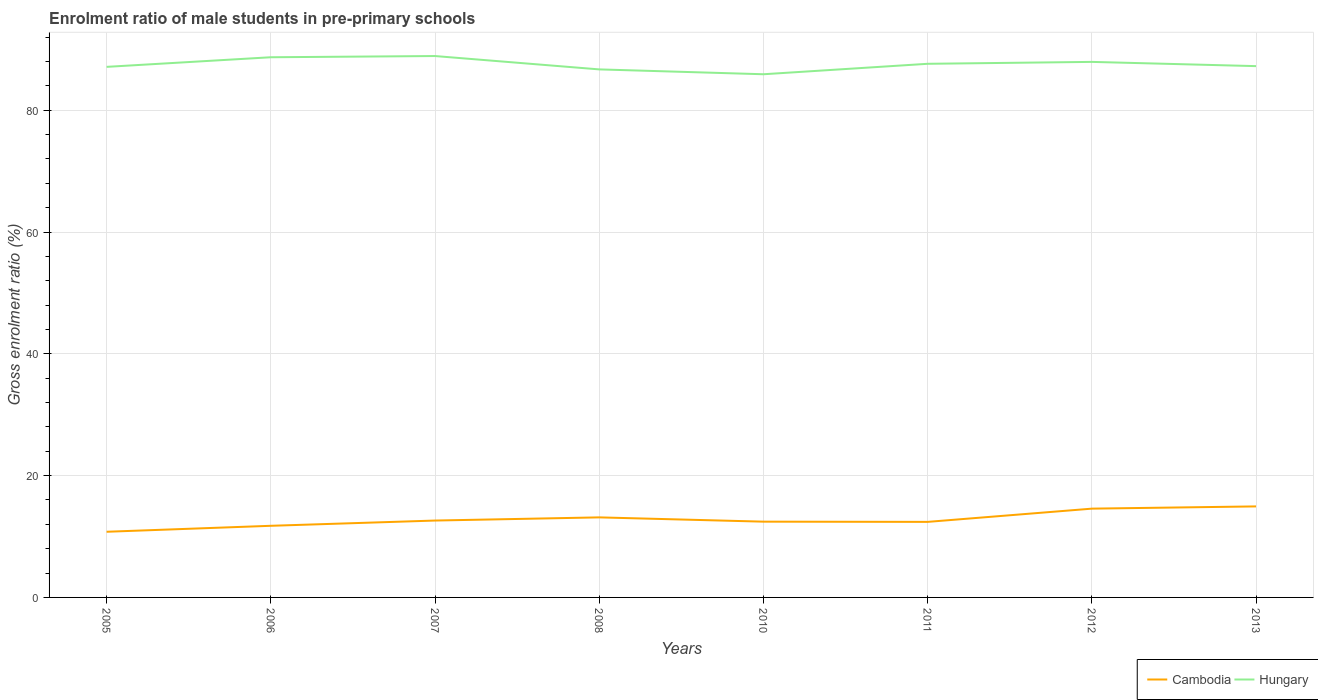Does the line corresponding to Cambodia intersect with the line corresponding to Hungary?
Your answer should be very brief. No. Is the number of lines equal to the number of legend labels?
Provide a succinct answer. Yes. Across all years, what is the maximum enrolment ratio of male students in pre-primary schools in Cambodia?
Your answer should be very brief. 10.78. What is the total enrolment ratio of male students in pre-primary schools in Cambodia in the graph?
Your response must be concise. 0.22. What is the difference between the highest and the second highest enrolment ratio of male students in pre-primary schools in Cambodia?
Provide a succinct answer. 4.16. How many lines are there?
Your answer should be very brief. 2. How many years are there in the graph?
Offer a terse response. 8. What is the difference between two consecutive major ticks on the Y-axis?
Ensure brevity in your answer.  20. Does the graph contain any zero values?
Provide a short and direct response. No. Does the graph contain grids?
Provide a succinct answer. Yes. How are the legend labels stacked?
Give a very brief answer. Horizontal. What is the title of the graph?
Ensure brevity in your answer.  Enrolment ratio of male students in pre-primary schools. What is the label or title of the X-axis?
Offer a terse response. Years. What is the label or title of the Y-axis?
Give a very brief answer. Gross enrolment ratio (%). What is the Gross enrolment ratio (%) of Cambodia in 2005?
Your answer should be compact. 10.78. What is the Gross enrolment ratio (%) of Hungary in 2005?
Give a very brief answer. 87.13. What is the Gross enrolment ratio (%) in Cambodia in 2006?
Your answer should be compact. 11.76. What is the Gross enrolment ratio (%) in Hungary in 2006?
Your response must be concise. 88.7. What is the Gross enrolment ratio (%) of Cambodia in 2007?
Offer a very short reply. 12.63. What is the Gross enrolment ratio (%) of Hungary in 2007?
Your response must be concise. 88.9. What is the Gross enrolment ratio (%) of Cambodia in 2008?
Your answer should be very brief. 13.15. What is the Gross enrolment ratio (%) of Hungary in 2008?
Your response must be concise. 86.71. What is the Gross enrolment ratio (%) in Cambodia in 2010?
Offer a very short reply. 12.44. What is the Gross enrolment ratio (%) in Hungary in 2010?
Your answer should be compact. 85.91. What is the Gross enrolment ratio (%) in Cambodia in 2011?
Keep it short and to the point. 12.41. What is the Gross enrolment ratio (%) in Hungary in 2011?
Ensure brevity in your answer.  87.63. What is the Gross enrolment ratio (%) in Cambodia in 2012?
Your response must be concise. 14.58. What is the Gross enrolment ratio (%) of Hungary in 2012?
Give a very brief answer. 87.94. What is the Gross enrolment ratio (%) of Cambodia in 2013?
Your answer should be very brief. 14.95. What is the Gross enrolment ratio (%) of Hungary in 2013?
Give a very brief answer. 87.25. Across all years, what is the maximum Gross enrolment ratio (%) in Cambodia?
Your answer should be compact. 14.95. Across all years, what is the maximum Gross enrolment ratio (%) in Hungary?
Provide a succinct answer. 88.9. Across all years, what is the minimum Gross enrolment ratio (%) in Cambodia?
Your answer should be very brief. 10.78. Across all years, what is the minimum Gross enrolment ratio (%) in Hungary?
Offer a very short reply. 85.91. What is the total Gross enrolment ratio (%) of Cambodia in the graph?
Give a very brief answer. 102.69. What is the total Gross enrolment ratio (%) of Hungary in the graph?
Give a very brief answer. 700.17. What is the difference between the Gross enrolment ratio (%) in Cambodia in 2005 and that in 2006?
Ensure brevity in your answer.  -0.98. What is the difference between the Gross enrolment ratio (%) in Hungary in 2005 and that in 2006?
Ensure brevity in your answer.  -1.58. What is the difference between the Gross enrolment ratio (%) in Cambodia in 2005 and that in 2007?
Give a very brief answer. -1.84. What is the difference between the Gross enrolment ratio (%) in Hungary in 2005 and that in 2007?
Ensure brevity in your answer.  -1.78. What is the difference between the Gross enrolment ratio (%) of Cambodia in 2005 and that in 2008?
Provide a succinct answer. -2.36. What is the difference between the Gross enrolment ratio (%) of Hungary in 2005 and that in 2008?
Your response must be concise. 0.42. What is the difference between the Gross enrolment ratio (%) of Cambodia in 2005 and that in 2010?
Provide a short and direct response. -1.66. What is the difference between the Gross enrolment ratio (%) of Hungary in 2005 and that in 2010?
Provide a succinct answer. 1.21. What is the difference between the Gross enrolment ratio (%) in Cambodia in 2005 and that in 2011?
Your answer should be compact. -1.62. What is the difference between the Gross enrolment ratio (%) of Hungary in 2005 and that in 2011?
Your answer should be very brief. -0.5. What is the difference between the Gross enrolment ratio (%) of Cambodia in 2005 and that in 2012?
Keep it short and to the point. -3.8. What is the difference between the Gross enrolment ratio (%) of Hungary in 2005 and that in 2012?
Provide a succinct answer. -0.82. What is the difference between the Gross enrolment ratio (%) of Cambodia in 2005 and that in 2013?
Your answer should be compact. -4.16. What is the difference between the Gross enrolment ratio (%) of Hungary in 2005 and that in 2013?
Provide a short and direct response. -0.12. What is the difference between the Gross enrolment ratio (%) of Cambodia in 2006 and that in 2007?
Your answer should be compact. -0.86. What is the difference between the Gross enrolment ratio (%) in Hungary in 2006 and that in 2007?
Ensure brevity in your answer.  -0.2. What is the difference between the Gross enrolment ratio (%) in Cambodia in 2006 and that in 2008?
Ensure brevity in your answer.  -1.38. What is the difference between the Gross enrolment ratio (%) in Hungary in 2006 and that in 2008?
Make the answer very short. 2. What is the difference between the Gross enrolment ratio (%) of Cambodia in 2006 and that in 2010?
Make the answer very short. -0.68. What is the difference between the Gross enrolment ratio (%) of Hungary in 2006 and that in 2010?
Your answer should be very brief. 2.79. What is the difference between the Gross enrolment ratio (%) of Cambodia in 2006 and that in 2011?
Provide a short and direct response. -0.64. What is the difference between the Gross enrolment ratio (%) of Hungary in 2006 and that in 2011?
Your answer should be compact. 1.08. What is the difference between the Gross enrolment ratio (%) of Cambodia in 2006 and that in 2012?
Offer a terse response. -2.82. What is the difference between the Gross enrolment ratio (%) of Hungary in 2006 and that in 2012?
Offer a very short reply. 0.76. What is the difference between the Gross enrolment ratio (%) of Cambodia in 2006 and that in 2013?
Ensure brevity in your answer.  -3.18. What is the difference between the Gross enrolment ratio (%) in Hungary in 2006 and that in 2013?
Your response must be concise. 1.46. What is the difference between the Gross enrolment ratio (%) of Cambodia in 2007 and that in 2008?
Your answer should be compact. -0.52. What is the difference between the Gross enrolment ratio (%) in Hungary in 2007 and that in 2008?
Provide a short and direct response. 2.19. What is the difference between the Gross enrolment ratio (%) in Cambodia in 2007 and that in 2010?
Provide a short and direct response. 0.18. What is the difference between the Gross enrolment ratio (%) of Hungary in 2007 and that in 2010?
Give a very brief answer. 2.99. What is the difference between the Gross enrolment ratio (%) of Cambodia in 2007 and that in 2011?
Provide a short and direct response. 0.22. What is the difference between the Gross enrolment ratio (%) of Hungary in 2007 and that in 2011?
Make the answer very short. 1.27. What is the difference between the Gross enrolment ratio (%) of Cambodia in 2007 and that in 2012?
Provide a short and direct response. -1.95. What is the difference between the Gross enrolment ratio (%) in Hungary in 2007 and that in 2012?
Your answer should be compact. 0.96. What is the difference between the Gross enrolment ratio (%) in Cambodia in 2007 and that in 2013?
Provide a succinct answer. -2.32. What is the difference between the Gross enrolment ratio (%) in Hungary in 2007 and that in 2013?
Your response must be concise. 1.66. What is the difference between the Gross enrolment ratio (%) of Cambodia in 2008 and that in 2010?
Offer a terse response. 0.7. What is the difference between the Gross enrolment ratio (%) of Hungary in 2008 and that in 2010?
Give a very brief answer. 0.8. What is the difference between the Gross enrolment ratio (%) of Cambodia in 2008 and that in 2011?
Provide a short and direct response. 0.74. What is the difference between the Gross enrolment ratio (%) in Hungary in 2008 and that in 2011?
Your response must be concise. -0.92. What is the difference between the Gross enrolment ratio (%) in Cambodia in 2008 and that in 2012?
Provide a succinct answer. -1.43. What is the difference between the Gross enrolment ratio (%) of Hungary in 2008 and that in 2012?
Provide a short and direct response. -1.23. What is the difference between the Gross enrolment ratio (%) in Cambodia in 2008 and that in 2013?
Keep it short and to the point. -1.8. What is the difference between the Gross enrolment ratio (%) of Hungary in 2008 and that in 2013?
Provide a succinct answer. -0.54. What is the difference between the Gross enrolment ratio (%) of Cambodia in 2010 and that in 2011?
Your response must be concise. 0.04. What is the difference between the Gross enrolment ratio (%) of Hungary in 2010 and that in 2011?
Your answer should be very brief. -1.72. What is the difference between the Gross enrolment ratio (%) of Cambodia in 2010 and that in 2012?
Provide a succinct answer. -2.14. What is the difference between the Gross enrolment ratio (%) of Hungary in 2010 and that in 2012?
Your response must be concise. -2.03. What is the difference between the Gross enrolment ratio (%) in Cambodia in 2010 and that in 2013?
Provide a short and direct response. -2.51. What is the difference between the Gross enrolment ratio (%) in Hungary in 2010 and that in 2013?
Ensure brevity in your answer.  -1.33. What is the difference between the Gross enrolment ratio (%) in Cambodia in 2011 and that in 2012?
Your answer should be very brief. -2.17. What is the difference between the Gross enrolment ratio (%) in Hungary in 2011 and that in 2012?
Ensure brevity in your answer.  -0.31. What is the difference between the Gross enrolment ratio (%) in Cambodia in 2011 and that in 2013?
Your answer should be very brief. -2.54. What is the difference between the Gross enrolment ratio (%) in Hungary in 2011 and that in 2013?
Your answer should be very brief. 0.38. What is the difference between the Gross enrolment ratio (%) in Cambodia in 2012 and that in 2013?
Give a very brief answer. -0.37. What is the difference between the Gross enrolment ratio (%) in Hungary in 2012 and that in 2013?
Offer a very short reply. 0.7. What is the difference between the Gross enrolment ratio (%) of Cambodia in 2005 and the Gross enrolment ratio (%) of Hungary in 2006?
Your answer should be very brief. -77.92. What is the difference between the Gross enrolment ratio (%) of Cambodia in 2005 and the Gross enrolment ratio (%) of Hungary in 2007?
Ensure brevity in your answer.  -78.12. What is the difference between the Gross enrolment ratio (%) in Cambodia in 2005 and the Gross enrolment ratio (%) in Hungary in 2008?
Offer a very short reply. -75.93. What is the difference between the Gross enrolment ratio (%) in Cambodia in 2005 and the Gross enrolment ratio (%) in Hungary in 2010?
Provide a short and direct response. -75.13. What is the difference between the Gross enrolment ratio (%) of Cambodia in 2005 and the Gross enrolment ratio (%) of Hungary in 2011?
Give a very brief answer. -76.85. What is the difference between the Gross enrolment ratio (%) of Cambodia in 2005 and the Gross enrolment ratio (%) of Hungary in 2012?
Your answer should be very brief. -77.16. What is the difference between the Gross enrolment ratio (%) of Cambodia in 2005 and the Gross enrolment ratio (%) of Hungary in 2013?
Give a very brief answer. -76.46. What is the difference between the Gross enrolment ratio (%) in Cambodia in 2006 and the Gross enrolment ratio (%) in Hungary in 2007?
Your answer should be compact. -77.14. What is the difference between the Gross enrolment ratio (%) of Cambodia in 2006 and the Gross enrolment ratio (%) of Hungary in 2008?
Your answer should be compact. -74.95. What is the difference between the Gross enrolment ratio (%) of Cambodia in 2006 and the Gross enrolment ratio (%) of Hungary in 2010?
Your answer should be compact. -74.15. What is the difference between the Gross enrolment ratio (%) of Cambodia in 2006 and the Gross enrolment ratio (%) of Hungary in 2011?
Make the answer very short. -75.87. What is the difference between the Gross enrolment ratio (%) in Cambodia in 2006 and the Gross enrolment ratio (%) in Hungary in 2012?
Keep it short and to the point. -76.18. What is the difference between the Gross enrolment ratio (%) in Cambodia in 2006 and the Gross enrolment ratio (%) in Hungary in 2013?
Offer a very short reply. -75.49. What is the difference between the Gross enrolment ratio (%) of Cambodia in 2007 and the Gross enrolment ratio (%) of Hungary in 2008?
Offer a terse response. -74.08. What is the difference between the Gross enrolment ratio (%) of Cambodia in 2007 and the Gross enrolment ratio (%) of Hungary in 2010?
Provide a short and direct response. -73.29. What is the difference between the Gross enrolment ratio (%) in Cambodia in 2007 and the Gross enrolment ratio (%) in Hungary in 2011?
Your answer should be very brief. -75. What is the difference between the Gross enrolment ratio (%) of Cambodia in 2007 and the Gross enrolment ratio (%) of Hungary in 2012?
Offer a terse response. -75.32. What is the difference between the Gross enrolment ratio (%) of Cambodia in 2007 and the Gross enrolment ratio (%) of Hungary in 2013?
Your response must be concise. -74.62. What is the difference between the Gross enrolment ratio (%) of Cambodia in 2008 and the Gross enrolment ratio (%) of Hungary in 2010?
Offer a terse response. -72.77. What is the difference between the Gross enrolment ratio (%) of Cambodia in 2008 and the Gross enrolment ratio (%) of Hungary in 2011?
Your response must be concise. -74.48. What is the difference between the Gross enrolment ratio (%) of Cambodia in 2008 and the Gross enrolment ratio (%) of Hungary in 2012?
Provide a short and direct response. -74.8. What is the difference between the Gross enrolment ratio (%) of Cambodia in 2008 and the Gross enrolment ratio (%) of Hungary in 2013?
Ensure brevity in your answer.  -74.1. What is the difference between the Gross enrolment ratio (%) in Cambodia in 2010 and the Gross enrolment ratio (%) in Hungary in 2011?
Keep it short and to the point. -75.19. What is the difference between the Gross enrolment ratio (%) of Cambodia in 2010 and the Gross enrolment ratio (%) of Hungary in 2012?
Provide a short and direct response. -75.5. What is the difference between the Gross enrolment ratio (%) in Cambodia in 2010 and the Gross enrolment ratio (%) in Hungary in 2013?
Make the answer very short. -74.81. What is the difference between the Gross enrolment ratio (%) in Cambodia in 2011 and the Gross enrolment ratio (%) in Hungary in 2012?
Your answer should be very brief. -75.54. What is the difference between the Gross enrolment ratio (%) of Cambodia in 2011 and the Gross enrolment ratio (%) of Hungary in 2013?
Make the answer very short. -74.84. What is the difference between the Gross enrolment ratio (%) of Cambodia in 2012 and the Gross enrolment ratio (%) of Hungary in 2013?
Offer a terse response. -72.67. What is the average Gross enrolment ratio (%) in Cambodia per year?
Your response must be concise. 12.84. What is the average Gross enrolment ratio (%) in Hungary per year?
Provide a short and direct response. 87.52. In the year 2005, what is the difference between the Gross enrolment ratio (%) in Cambodia and Gross enrolment ratio (%) in Hungary?
Give a very brief answer. -76.34. In the year 2006, what is the difference between the Gross enrolment ratio (%) of Cambodia and Gross enrolment ratio (%) of Hungary?
Provide a succinct answer. -76.94. In the year 2007, what is the difference between the Gross enrolment ratio (%) in Cambodia and Gross enrolment ratio (%) in Hungary?
Offer a terse response. -76.28. In the year 2008, what is the difference between the Gross enrolment ratio (%) of Cambodia and Gross enrolment ratio (%) of Hungary?
Provide a short and direct response. -73.56. In the year 2010, what is the difference between the Gross enrolment ratio (%) in Cambodia and Gross enrolment ratio (%) in Hungary?
Offer a very short reply. -73.47. In the year 2011, what is the difference between the Gross enrolment ratio (%) of Cambodia and Gross enrolment ratio (%) of Hungary?
Offer a terse response. -75.22. In the year 2012, what is the difference between the Gross enrolment ratio (%) of Cambodia and Gross enrolment ratio (%) of Hungary?
Your response must be concise. -73.36. In the year 2013, what is the difference between the Gross enrolment ratio (%) of Cambodia and Gross enrolment ratio (%) of Hungary?
Keep it short and to the point. -72.3. What is the ratio of the Gross enrolment ratio (%) in Hungary in 2005 to that in 2006?
Your answer should be very brief. 0.98. What is the ratio of the Gross enrolment ratio (%) of Cambodia in 2005 to that in 2007?
Offer a very short reply. 0.85. What is the ratio of the Gross enrolment ratio (%) in Hungary in 2005 to that in 2007?
Your answer should be very brief. 0.98. What is the ratio of the Gross enrolment ratio (%) in Cambodia in 2005 to that in 2008?
Offer a terse response. 0.82. What is the ratio of the Gross enrolment ratio (%) in Cambodia in 2005 to that in 2010?
Offer a terse response. 0.87. What is the ratio of the Gross enrolment ratio (%) of Hungary in 2005 to that in 2010?
Provide a succinct answer. 1.01. What is the ratio of the Gross enrolment ratio (%) of Cambodia in 2005 to that in 2011?
Offer a terse response. 0.87. What is the ratio of the Gross enrolment ratio (%) in Cambodia in 2005 to that in 2012?
Your answer should be compact. 0.74. What is the ratio of the Gross enrolment ratio (%) in Hungary in 2005 to that in 2012?
Make the answer very short. 0.99. What is the ratio of the Gross enrolment ratio (%) of Cambodia in 2005 to that in 2013?
Make the answer very short. 0.72. What is the ratio of the Gross enrolment ratio (%) in Hungary in 2005 to that in 2013?
Offer a terse response. 1. What is the ratio of the Gross enrolment ratio (%) of Cambodia in 2006 to that in 2007?
Ensure brevity in your answer.  0.93. What is the ratio of the Gross enrolment ratio (%) in Hungary in 2006 to that in 2007?
Make the answer very short. 1. What is the ratio of the Gross enrolment ratio (%) in Cambodia in 2006 to that in 2008?
Provide a short and direct response. 0.89. What is the ratio of the Gross enrolment ratio (%) in Cambodia in 2006 to that in 2010?
Keep it short and to the point. 0.95. What is the ratio of the Gross enrolment ratio (%) of Hungary in 2006 to that in 2010?
Offer a terse response. 1.03. What is the ratio of the Gross enrolment ratio (%) in Cambodia in 2006 to that in 2011?
Your response must be concise. 0.95. What is the ratio of the Gross enrolment ratio (%) of Hungary in 2006 to that in 2011?
Your answer should be compact. 1.01. What is the ratio of the Gross enrolment ratio (%) in Cambodia in 2006 to that in 2012?
Make the answer very short. 0.81. What is the ratio of the Gross enrolment ratio (%) in Hungary in 2006 to that in 2012?
Make the answer very short. 1.01. What is the ratio of the Gross enrolment ratio (%) in Cambodia in 2006 to that in 2013?
Keep it short and to the point. 0.79. What is the ratio of the Gross enrolment ratio (%) of Hungary in 2006 to that in 2013?
Your response must be concise. 1.02. What is the ratio of the Gross enrolment ratio (%) of Cambodia in 2007 to that in 2008?
Make the answer very short. 0.96. What is the ratio of the Gross enrolment ratio (%) in Hungary in 2007 to that in 2008?
Offer a very short reply. 1.03. What is the ratio of the Gross enrolment ratio (%) in Cambodia in 2007 to that in 2010?
Make the answer very short. 1.01. What is the ratio of the Gross enrolment ratio (%) in Hungary in 2007 to that in 2010?
Offer a very short reply. 1.03. What is the ratio of the Gross enrolment ratio (%) of Cambodia in 2007 to that in 2011?
Offer a terse response. 1.02. What is the ratio of the Gross enrolment ratio (%) in Hungary in 2007 to that in 2011?
Keep it short and to the point. 1.01. What is the ratio of the Gross enrolment ratio (%) of Cambodia in 2007 to that in 2012?
Your answer should be compact. 0.87. What is the ratio of the Gross enrolment ratio (%) of Hungary in 2007 to that in 2012?
Provide a short and direct response. 1.01. What is the ratio of the Gross enrolment ratio (%) of Cambodia in 2007 to that in 2013?
Offer a terse response. 0.84. What is the ratio of the Gross enrolment ratio (%) of Hungary in 2007 to that in 2013?
Provide a succinct answer. 1.02. What is the ratio of the Gross enrolment ratio (%) of Cambodia in 2008 to that in 2010?
Give a very brief answer. 1.06. What is the ratio of the Gross enrolment ratio (%) in Hungary in 2008 to that in 2010?
Ensure brevity in your answer.  1.01. What is the ratio of the Gross enrolment ratio (%) of Cambodia in 2008 to that in 2011?
Your response must be concise. 1.06. What is the ratio of the Gross enrolment ratio (%) in Hungary in 2008 to that in 2011?
Ensure brevity in your answer.  0.99. What is the ratio of the Gross enrolment ratio (%) of Cambodia in 2008 to that in 2012?
Your answer should be very brief. 0.9. What is the ratio of the Gross enrolment ratio (%) of Hungary in 2008 to that in 2012?
Provide a succinct answer. 0.99. What is the ratio of the Gross enrolment ratio (%) in Cambodia in 2008 to that in 2013?
Ensure brevity in your answer.  0.88. What is the ratio of the Gross enrolment ratio (%) in Hungary in 2008 to that in 2013?
Your response must be concise. 0.99. What is the ratio of the Gross enrolment ratio (%) of Hungary in 2010 to that in 2011?
Your answer should be very brief. 0.98. What is the ratio of the Gross enrolment ratio (%) of Cambodia in 2010 to that in 2012?
Offer a very short reply. 0.85. What is the ratio of the Gross enrolment ratio (%) in Hungary in 2010 to that in 2012?
Keep it short and to the point. 0.98. What is the ratio of the Gross enrolment ratio (%) of Cambodia in 2010 to that in 2013?
Your answer should be compact. 0.83. What is the ratio of the Gross enrolment ratio (%) in Hungary in 2010 to that in 2013?
Your response must be concise. 0.98. What is the ratio of the Gross enrolment ratio (%) of Cambodia in 2011 to that in 2012?
Provide a succinct answer. 0.85. What is the ratio of the Gross enrolment ratio (%) of Cambodia in 2011 to that in 2013?
Make the answer very short. 0.83. What is the ratio of the Gross enrolment ratio (%) of Cambodia in 2012 to that in 2013?
Keep it short and to the point. 0.98. What is the difference between the highest and the second highest Gross enrolment ratio (%) of Cambodia?
Offer a terse response. 0.37. What is the difference between the highest and the second highest Gross enrolment ratio (%) in Hungary?
Provide a short and direct response. 0.2. What is the difference between the highest and the lowest Gross enrolment ratio (%) of Cambodia?
Your answer should be compact. 4.16. What is the difference between the highest and the lowest Gross enrolment ratio (%) of Hungary?
Provide a short and direct response. 2.99. 